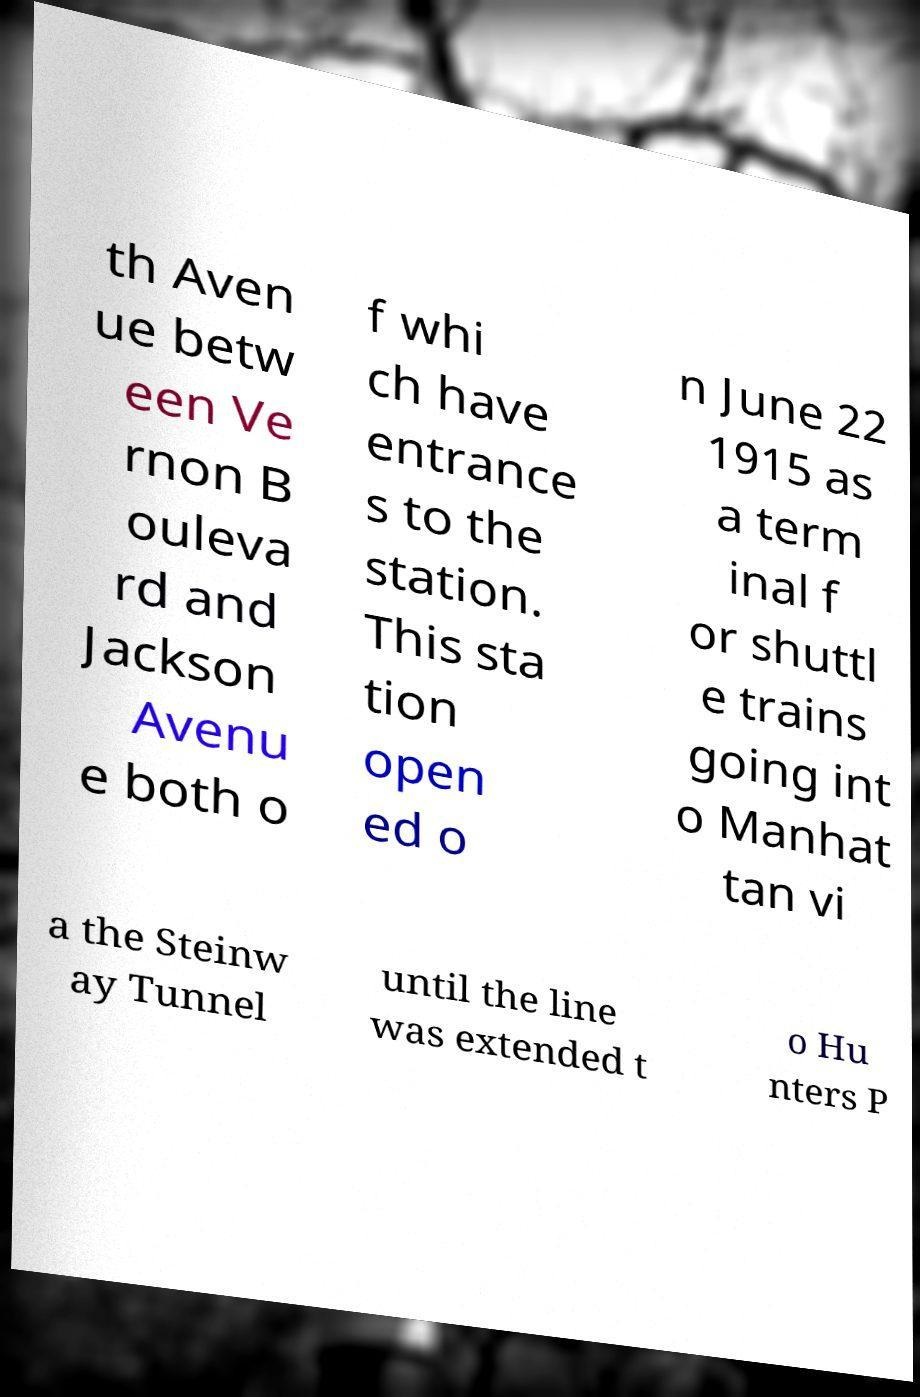Can you accurately transcribe the text from the provided image for me? th Aven ue betw een Ve rnon B ouleva rd and Jackson Avenu e both o f whi ch have entrance s to the station. This sta tion open ed o n June 22 1915 as a term inal f or shuttl e trains going int o Manhat tan vi a the Steinw ay Tunnel until the line was extended t o Hu nters P 